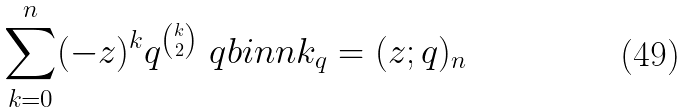<formula> <loc_0><loc_0><loc_500><loc_500>\sum _ { k = 0 } ^ { n } ( - z ) ^ { k } q ^ { \binom { k } { 2 } } \ q b i n { n } { k } _ { q } = ( z ; q ) _ { n }</formula> 